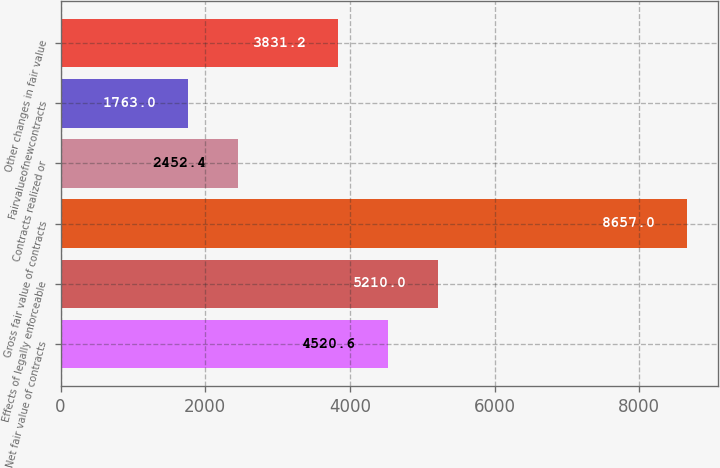Convert chart to OTSL. <chart><loc_0><loc_0><loc_500><loc_500><bar_chart><fcel>Net fair value of contracts<fcel>Effects of legally enforceable<fcel>Gross fair value of contracts<fcel>Contracts realized or<fcel>Fairvalueofnewcontracts<fcel>Other changes in fair value<nl><fcel>4520.6<fcel>5210<fcel>8657<fcel>2452.4<fcel>1763<fcel>3831.2<nl></chart> 